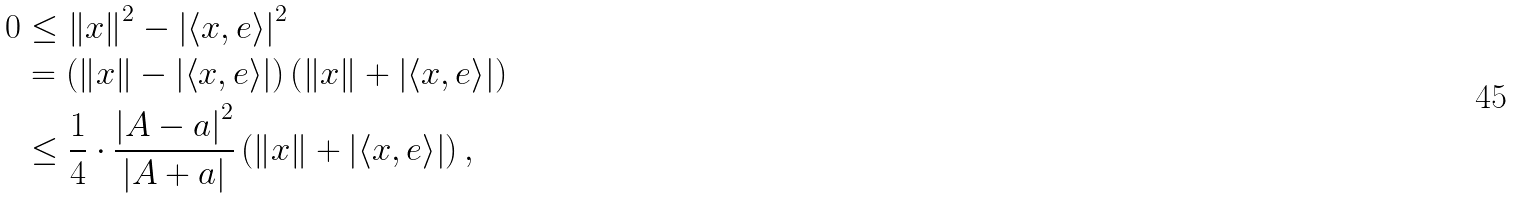<formula> <loc_0><loc_0><loc_500><loc_500>0 & \leq \left \| x \right \| ^ { 2 } - \left | \left \langle x , e \right \rangle \right | ^ { 2 } \\ & = \left ( \left \| x \right \| - \left | \left \langle x , e \right \rangle \right | \right ) \left ( \left \| x \right \| + \left | \left \langle x , e \right \rangle \right | \right ) \\ & \leq \frac { 1 } { 4 } \cdot \frac { \left | A - a \right | ^ { 2 } } { \left | A + a \right | } \left ( \left \| x \right \| + \left | \left \langle x , e \right \rangle \right | \right ) ,</formula> 